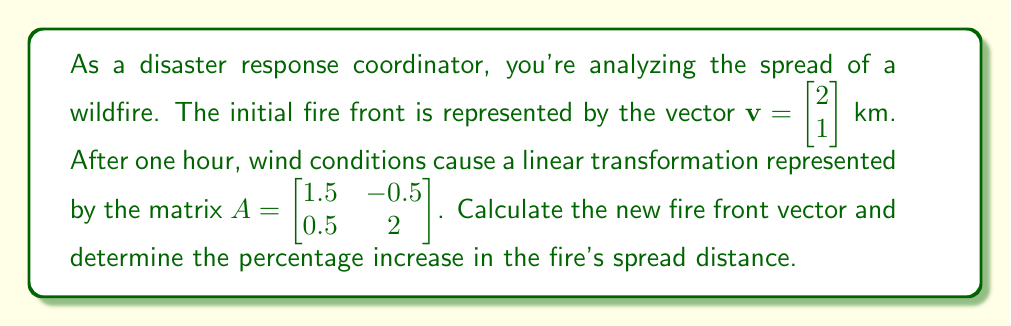Solve this math problem. To solve this problem, we'll follow these steps:

1) Apply the linear transformation to the initial fire front vector:
   $$\mathbf{v}_{new} = A\mathbf{v} = \begin{bmatrix} 1.5 & -0.5 \\ 0.5 & 2 \end{bmatrix} \begin{bmatrix} 2 \\ 1 \end{bmatrix}$$

2) Perform the matrix multiplication:
   $$\mathbf{v}_{new} = \begin{bmatrix} (1.5 \cdot 2) + (-0.5 \cdot 1) \\ (0.5 \cdot 2) + (2 \cdot 1) \end{bmatrix} = \begin{bmatrix} 2.5 \\ 3 \end{bmatrix}$$

3) Calculate the magnitude (length) of the initial vector:
   $$\|\mathbf{v}\| = \sqrt{2^2 + 1^2} = \sqrt{5} \approx 2.24 \text{ km}$$

4) Calculate the magnitude of the new vector:
   $$\|\mathbf{v}_{new}\| = \sqrt{2.5^2 + 3^2} = \sqrt{15.25} \approx 3.91 \text{ km}$$

5) Calculate the percentage increase:
   $$\text{Percentage increase} = \frac{\|\mathbf{v}_{new}\| - \|\mathbf{v}\|}{\|\mathbf{v}\|} \cdot 100\%$$
   $$= \frac{3.91 - 2.24}{2.24} \cdot 100\% \approx 74.55\%$$
Answer: The new fire front vector is $\mathbf{v}_{new} = \begin{bmatrix} 2.5 \\ 3 \end{bmatrix}$ km, and the percentage increase in the fire's spread distance is approximately 74.55%. 